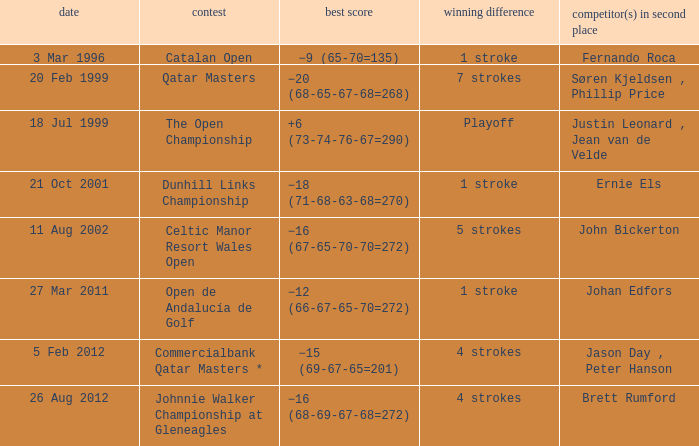What is the winning score for the runner-up Ernie Els? −18 (71-68-63-68=270). 